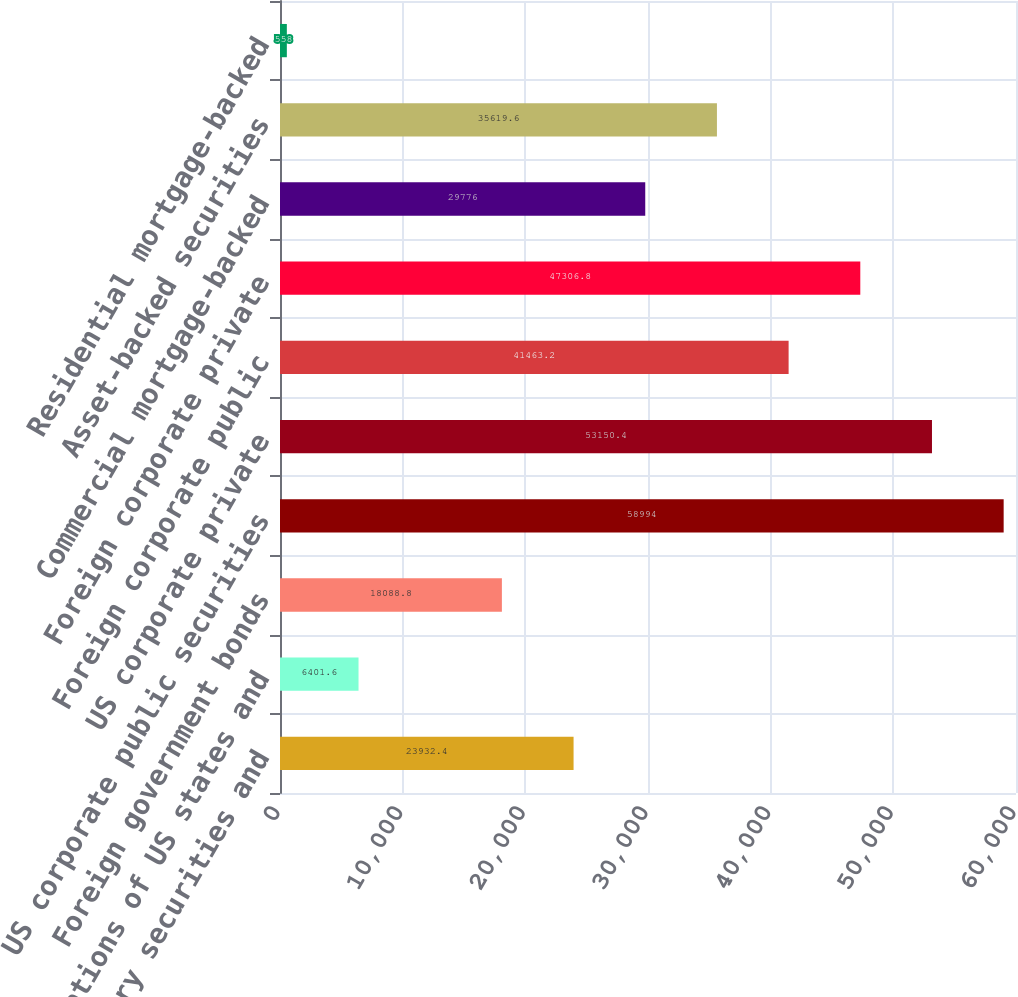Convert chart to OTSL. <chart><loc_0><loc_0><loc_500><loc_500><bar_chart><fcel>US Treasury securities and<fcel>Obligations of US states and<fcel>Foreign government bonds<fcel>US corporate public securities<fcel>US corporate private<fcel>Foreign corporate public<fcel>Foreign corporate private<fcel>Commercial mortgage-backed<fcel>Asset-backed securities<fcel>Residential mortgage-backed<nl><fcel>23932.4<fcel>6401.6<fcel>18088.8<fcel>58994<fcel>53150.4<fcel>41463.2<fcel>47306.8<fcel>29776<fcel>35619.6<fcel>558<nl></chart> 